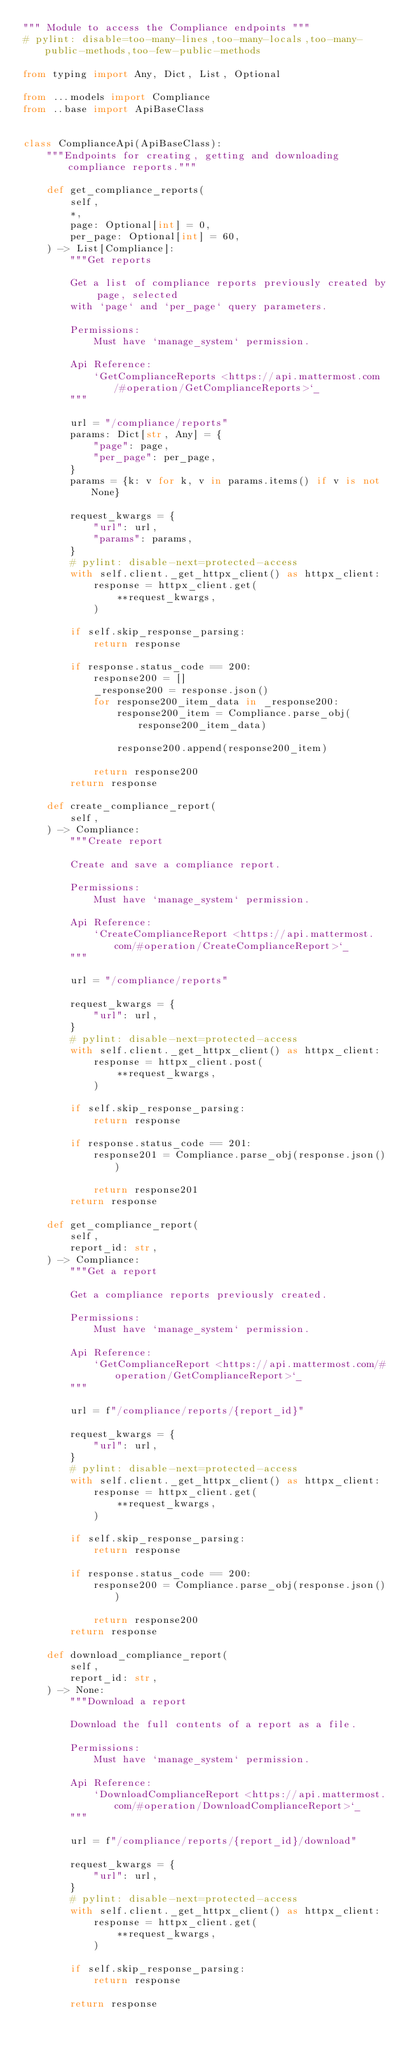Convert code to text. <code><loc_0><loc_0><loc_500><loc_500><_Python_>""" Module to access the Compliance endpoints """
# pylint: disable=too-many-lines,too-many-locals,too-many-public-methods,too-few-public-methods

from typing import Any, Dict, List, Optional

from ...models import Compliance
from ..base import ApiBaseClass


class ComplianceApi(ApiBaseClass):
    """Endpoints for creating, getting and downloading compliance reports."""

    def get_compliance_reports(
        self,
        *,
        page: Optional[int] = 0,
        per_page: Optional[int] = 60,
    ) -> List[Compliance]:
        """Get reports

        Get a list of compliance reports previously created by page, selected
        with `page` and `per_page` query parameters.

        Permissions:
            Must have `manage_system` permission.

        Api Reference:
            `GetComplianceReports <https://api.mattermost.com/#operation/GetComplianceReports>`_
        """

        url = "/compliance/reports"
        params: Dict[str, Any] = {
            "page": page,
            "per_page": per_page,
        }
        params = {k: v for k, v in params.items() if v is not None}

        request_kwargs = {
            "url": url,
            "params": params,
        }
        # pylint: disable-next=protected-access
        with self.client._get_httpx_client() as httpx_client:
            response = httpx_client.get(
                **request_kwargs,
            )

        if self.skip_response_parsing:
            return response

        if response.status_code == 200:
            response200 = []
            _response200 = response.json()
            for response200_item_data in _response200:
                response200_item = Compliance.parse_obj(response200_item_data)

                response200.append(response200_item)

            return response200
        return response

    def create_compliance_report(
        self,
    ) -> Compliance:
        """Create report

        Create and save a compliance report.

        Permissions:
            Must have `manage_system` permission.

        Api Reference:
            `CreateComplianceReport <https://api.mattermost.com/#operation/CreateComplianceReport>`_
        """

        url = "/compliance/reports"

        request_kwargs = {
            "url": url,
        }
        # pylint: disable-next=protected-access
        with self.client._get_httpx_client() as httpx_client:
            response = httpx_client.post(
                **request_kwargs,
            )

        if self.skip_response_parsing:
            return response

        if response.status_code == 201:
            response201 = Compliance.parse_obj(response.json())

            return response201
        return response

    def get_compliance_report(
        self,
        report_id: str,
    ) -> Compliance:
        """Get a report

        Get a compliance reports previously created.

        Permissions:
            Must have `manage_system` permission.

        Api Reference:
            `GetComplianceReport <https://api.mattermost.com/#operation/GetComplianceReport>`_
        """

        url = f"/compliance/reports/{report_id}"

        request_kwargs = {
            "url": url,
        }
        # pylint: disable-next=protected-access
        with self.client._get_httpx_client() as httpx_client:
            response = httpx_client.get(
                **request_kwargs,
            )

        if self.skip_response_parsing:
            return response

        if response.status_code == 200:
            response200 = Compliance.parse_obj(response.json())

            return response200
        return response

    def download_compliance_report(
        self,
        report_id: str,
    ) -> None:
        """Download a report

        Download the full contents of a report as a file.

        Permissions:
            Must have `manage_system` permission.

        Api Reference:
            `DownloadComplianceReport <https://api.mattermost.com/#operation/DownloadComplianceReport>`_
        """

        url = f"/compliance/reports/{report_id}/download"

        request_kwargs = {
            "url": url,
        }
        # pylint: disable-next=protected-access
        with self.client._get_httpx_client() as httpx_client:
            response = httpx_client.get(
                **request_kwargs,
            )

        if self.skip_response_parsing:
            return response

        return response
</code> 